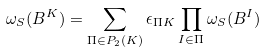Convert formula to latex. <formula><loc_0><loc_0><loc_500><loc_500>\omega _ { S } ( B ^ { K } ) = \sum _ { \Pi \in P _ { 2 } ( K ) } \epsilon _ { \Pi K } \prod _ { I \in \Pi } \omega _ { S } ( B ^ { I } )</formula> 